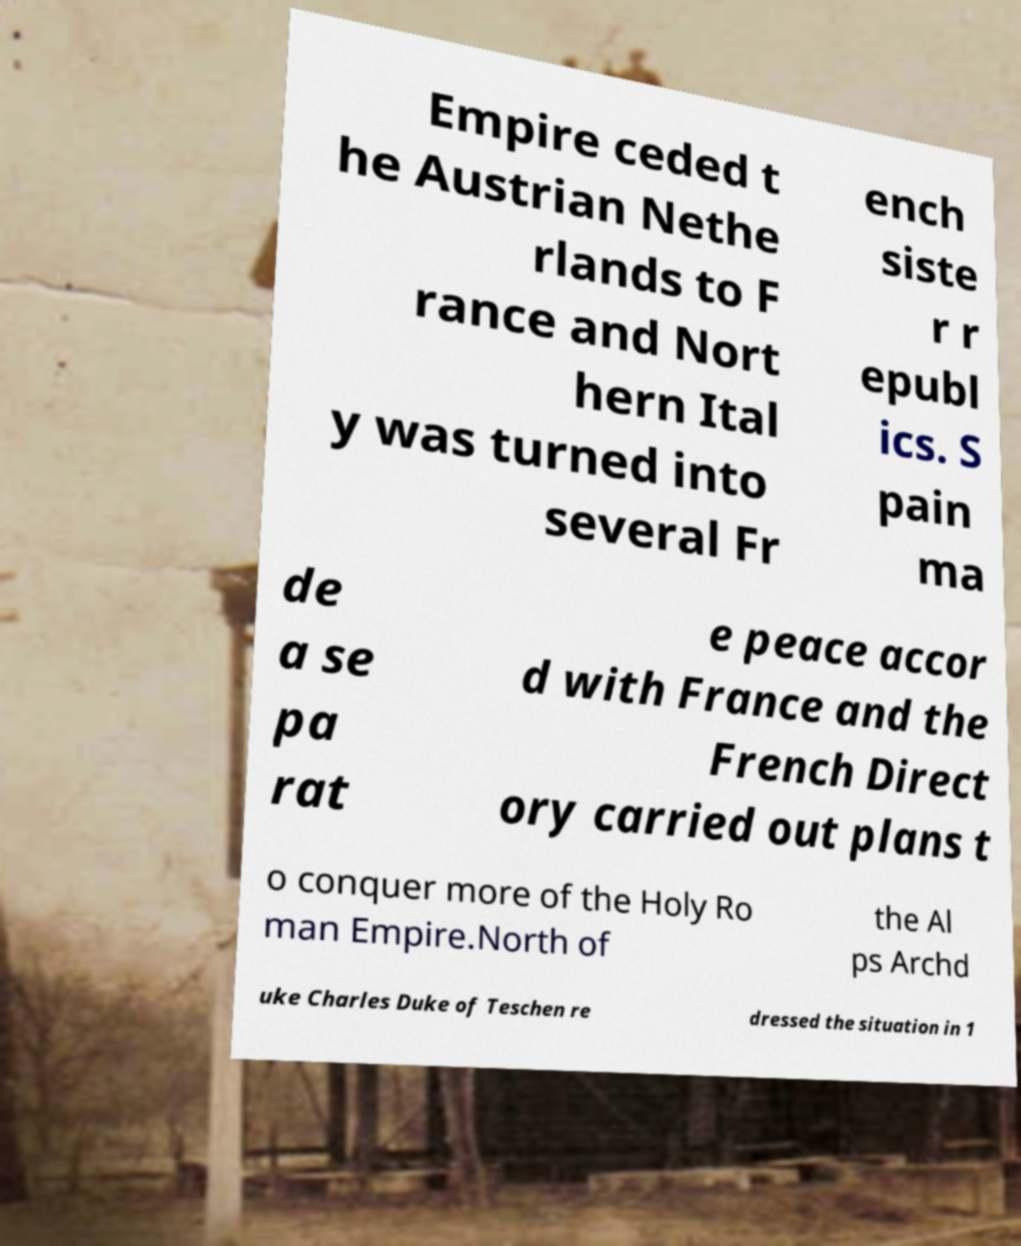Can you accurately transcribe the text from the provided image for me? Empire ceded t he Austrian Nethe rlands to F rance and Nort hern Ital y was turned into several Fr ench siste r r epubl ics. S pain ma de a se pa rat e peace accor d with France and the French Direct ory carried out plans t o conquer more of the Holy Ro man Empire.North of the Al ps Archd uke Charles Duke of Teschen re dressed the situation in 1 